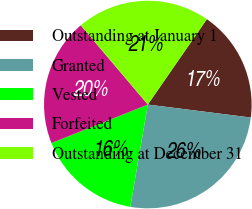<chart> <loc_0><loc_0><loc_500><loc_500><pie_chart><fcel>Outstanding at January 1<fcel>Granted<fcel>Vested<fcel>Forfeited<fcel>Outstanding at December 31<nl><fcel>17.37%<fcel>25.7%<fcel>16.26%<fcel>19.86%<fcel>20.81%<nl></chart> 